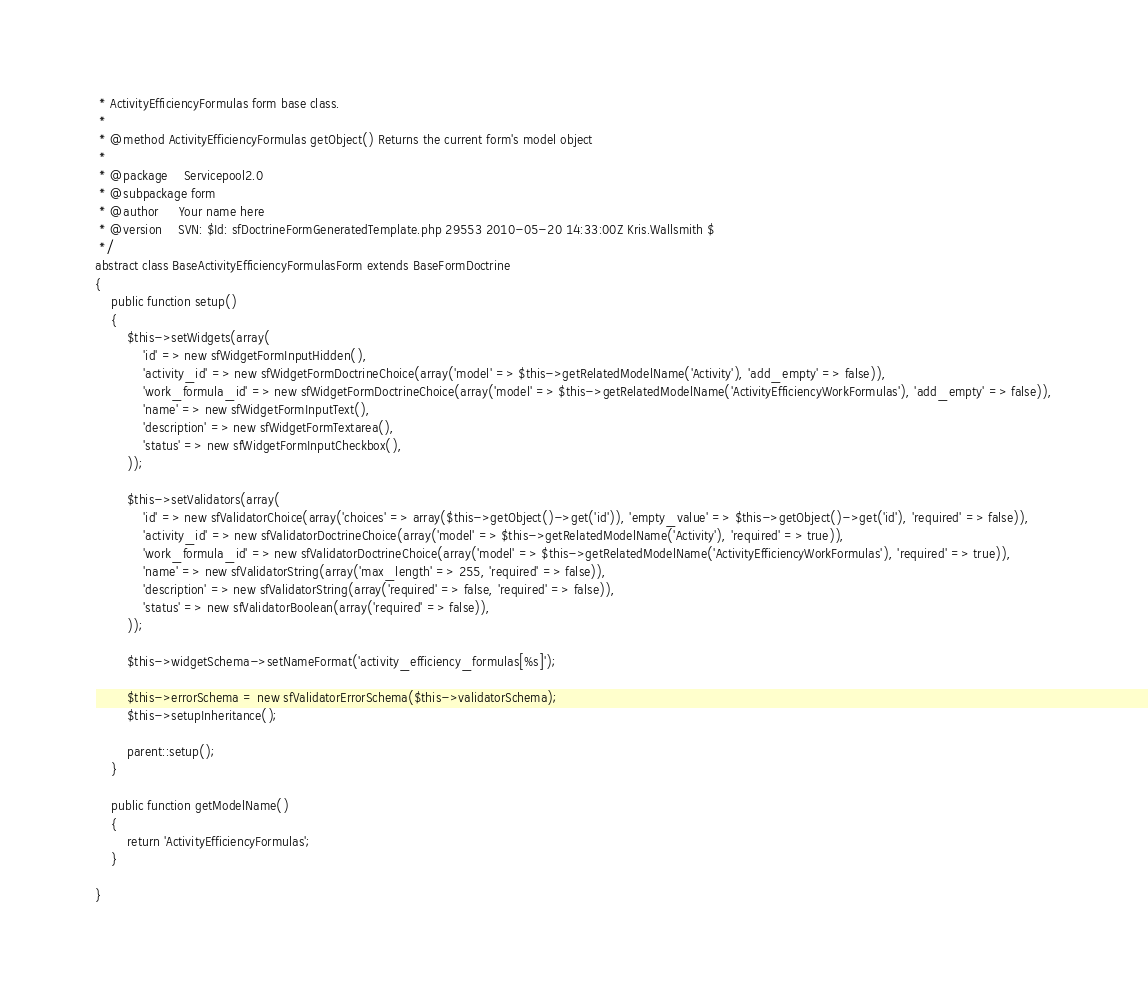<code> <loc_0><loc_0><loc_500><loc_500><_PHP_> * ActivityEfficiencyFormulas form base class.
 *
 * @method ActivityEfficiencyFormulas getObject() Returns the current form's model object
 *
 * @package    Servicepool2.0
 * @subpackage form
 * @author     Your name here
 * @version    SVN: $Id: sfDoctrineFormGeneratedTemplate.php 29553 2010-05-20 14:33:00Z Kris.Wallsmith $
 */
abstract class BaseActivityEfficiencyFormulasForm extends BaseFormDoctrine
{
    public function setup()
    {
        $this->setWidgets(array(
            'id' => new sfWidgetFormInputHidden(),
            'activity_id' => new sfWidgetFormDoctrineChoice(array('model' => $this->getRelatedModelName('Activity'), 'add_empty' => false)),
            'work_formula_id' => new sfWidgetFormDoctrineChoice(array('model' => $this->getRelatedModelName('ActivityEfficiencyWorkFormulas'), 'add_empty' => false)),
            'name' => new sfWidgetFormInputText(),
            'description' => new sfWidgetFormTextarea(),
            'status' => new sfWidgetFormInputCheckbox(),
        ));

        $this->setValidators(array(
            'id' => new sfValidatorChoice(array('choices' => array($this->getObject()->get('id')), 'empty_value' => $this->getObject()->get('id'), 'required' => false)),
            'activity_id' => new sfValidatorDoctrineChoice(array('model' => $this->getRelatedModelName('Activity'), 'required' => true)),
            'work_formula_id' => new sfValidatorDoctrineChoice(array('model' => $this->getRelatedModelName('ActivityEfficiencyWorkFormulas'), 'required' => true)),
            'name' => new sfValidatorString(array('max_length' => 255, 'required' => false)),
            'description' => new sfValidatorString(array('required' => false, 'required' => false)),
            'status' => new sfValidatorBoolean(array('required' => false)),
        ));

        $this->widgetSchema->setNameFormat('activity_efficiency_formulas[%s]');

        $this->errorSchema = new sfValidatorErrorSchema($this->validatorSchema);
        $this->setupInheritance();

        parent::setup();
    }

    public function getModelName()
    {
        return 'ActivityEfficiencyFormulas';
    }

}
</code> 